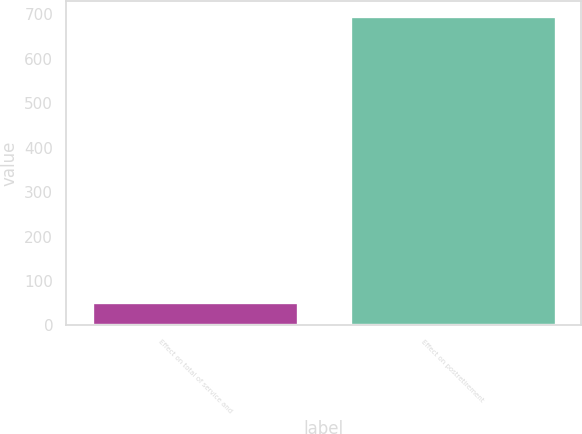<chart> <loc_0><loc_0><loc_500><loc_500><bar_chart><fcel>Effect on total of service and<fcel>Effect on postretirement<nl><fcel>52<fcel>695<nl></chart> 